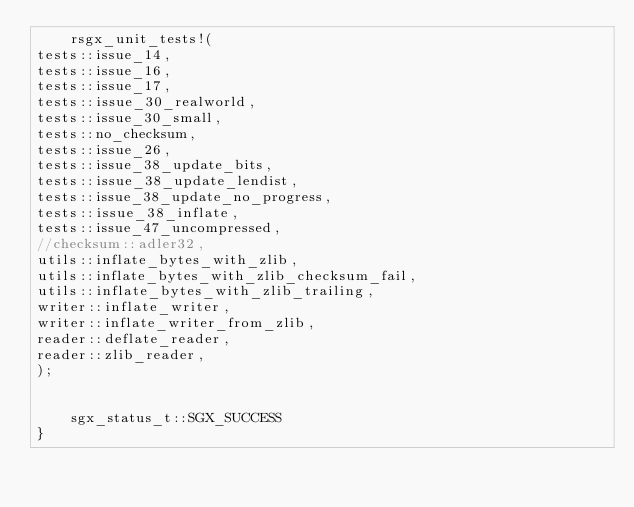<code> <loc_0><loc_0><loc_500><loc_500><_Rust_>    rsgx_unit_tests!(
tests::issue_14,
tests::issue_16,
tests::issue_17,
tests::issue_30_realworld,
tests::issue_30_small,
tests::no_checksum,
tests::issue_26,
tests::issue_38_update_bits,
tests::issue_38_update_lendist,
tests::issue_38_update_no_progress,
tests::issue_38_inflate,
tests::issue_47_uncompressed,
//checksum::adler32,
utils::inflate_bytes_with_zlib,
utils::inflate_bytes_with_zlib_checksum_fail,
utils::inflate_bytes_with_zlib_trailing,
writer::inflate_writer,
writer::inflate_writer_from_zlib,
reader::deflate_reader,
reader::zlib_reader,
);


    sgx_status_t::SGX_SUCCESS
}
</code> 